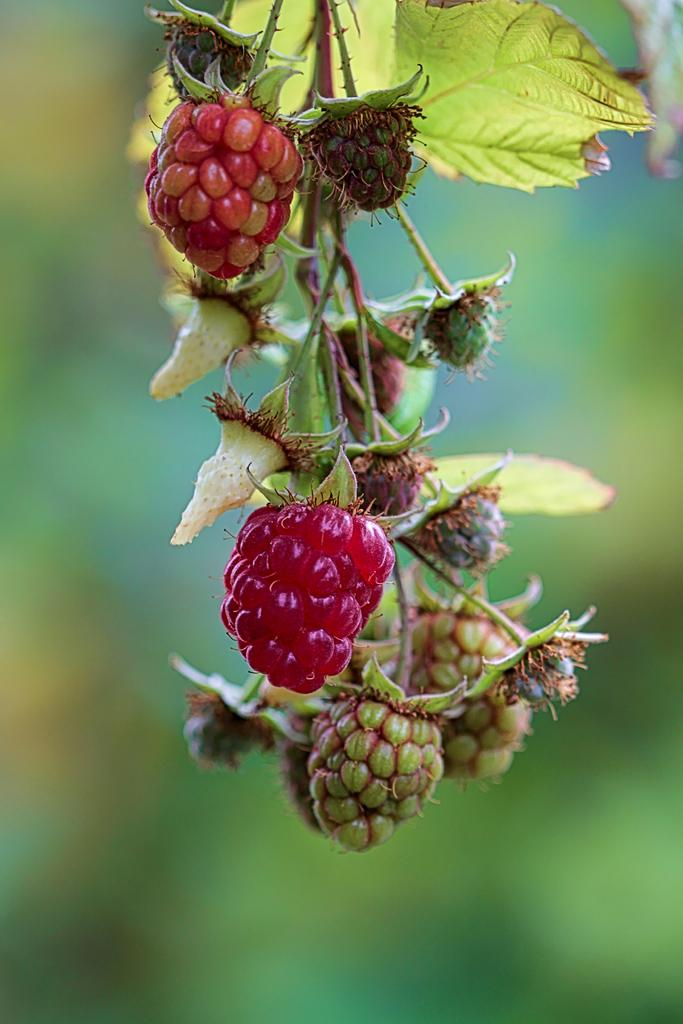What type of food can be seen in the image? There are fruits in the image. Can you tell me where the fruits come from? The fruits are from a tree. What type of government is depicted in the image? There is no government depicted in the image; it features fruits from a tree. Is the table on fire in the image? There is no table present in the image, so it cannot be on fire. 